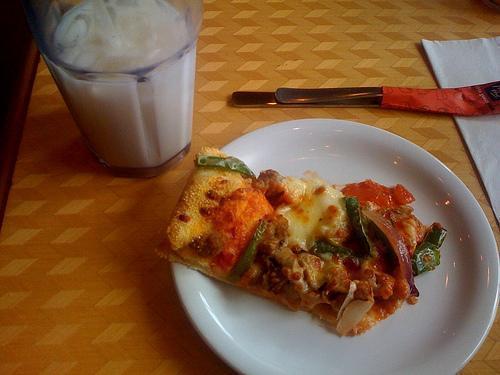How has this food been prepared for serving?
Choose the right answer from the provided options to respond to the question.
Options: Grated, scooped, sliced, poured. Sliced. 